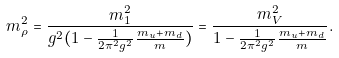<formula> <loc_0><loc_0><loc_500><loc_500>m _ { \rho } ^ { 2 } = \frac { m ^ { 2 } _ { 1 } } { g ^ { 2 } ( 1 - \frac { 1 } { 2 \pi ^ { 2 } g ^ { 2 } } \frac { m _ { u } + m _ { d } } { m } ) } = \frac { m _ { V } ^ { 2 } } { 1 - \frac { 1 } { 2 \pi ^ { 2 } g ^ { 2 } } \frac { m _ { u } + m _ { d } } { m } } .</formula> 